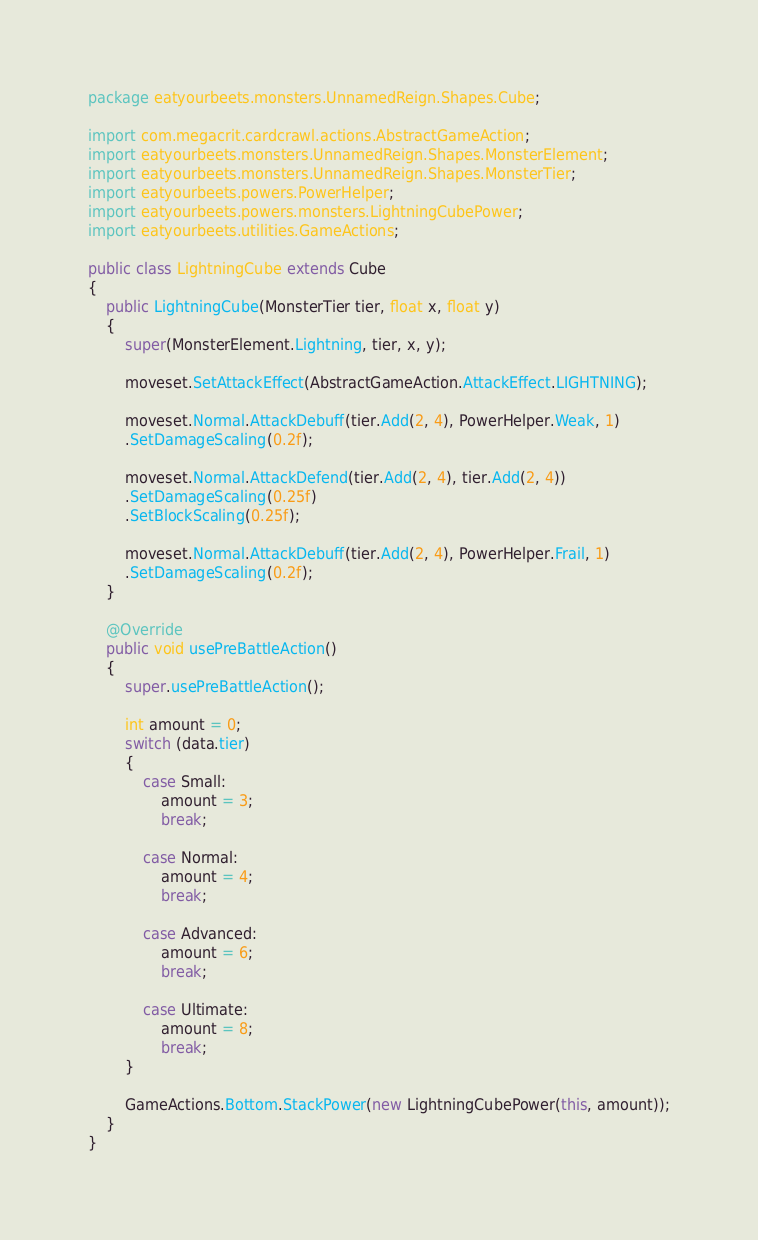<code> <loc_0><loc_0><loc_500><loc_500><_Java_>package eatyourbeets.monsters.UnnamedReign.Shapes.Cube;

import com.megacrit.cardcrawl.actions.AbstractGameAction;
import eatyourbeets.monsters.UnnamedReign.Shapes.MonsterElement;
import eatyourbeets.monsters.UnnamedReign.Shapes.MonsterTier;
import eatyourbeets.powers.PowerHelper;
import eatyourbeets.powers.monsters.LightningCubePower;
import eatyourbeets.utilities.GameActions;

public class LightningCube extends Cube
{
    public LightningCube(MonsterTier tier, float x, float y)
    {
        super(MonsterElement.Lightning, tier, x, y);

        moveset.SetAttackEffect(AbstractGameAction.AttackEffect.LIGHTNING);

        moveset.Normal.AttackDebuff(tier.Add(2, 4), PowerHelper.Weak, 1)
        .SetDamageScaling(0.2f);

        moveset.Normal.AttackDefend(tier.Add(2, 4), tier.Add(2, 4))
        .SetDamageScaling(0.25f)
        .SetBlockScaling(0.25f);

        moveset.Normal.AttackDebuff(tier.Add(2, 4), PowerHelper.Frail, 1)
        .SetDamageScaling(0.2f);
    }

    @Override
    public void usePreBattleAction()
    {
        super.usePreBattleAction();

        int amount = 0;
        switch (data.tier)
        {
            case Small:
                amount = 3;
                break;

            case Normal:
                amount = 4;
                break;

            case Advanced:
                amount = 6;
                break;

            case Ultimate:
                amount = 8;
                break;
        }

        GameActions.Bottom.StackPower(new LightningCubePower(this, amount));
    }
}
</code> 